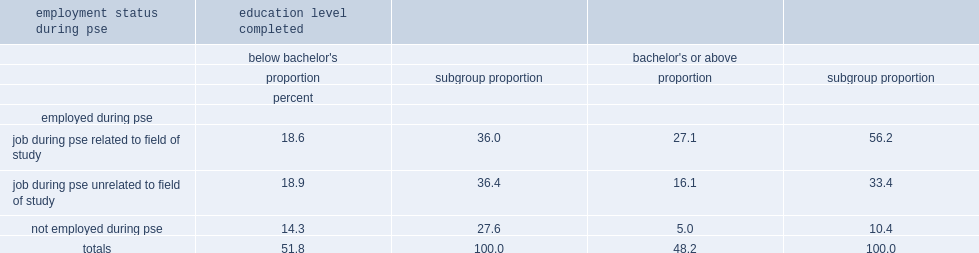What was the percentage of those that completed a degree at the bachelor's level or above who had a job related to their field of study? 56.2. What was the percentage of graduates with a degree below the bachelor's level who had a job at some point during their pse? 72.4. 